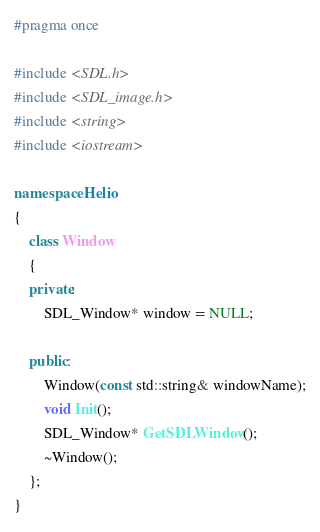<code> <loc_0><loc_0><loc_500><loc_500><_C++_>#pragma once

#include <SDL.h>
#include <SDL_image.h>
#include <string>
#include <iostream>

namespace Helio
{
	class Window
	{
	private:
		SDL_Window* window = NULL;
	
	public:
		Window(const std::string& windowName);
		void Init();
		SDL_Window* GetSDLWindow();
		~Window();
	};
}</code> 